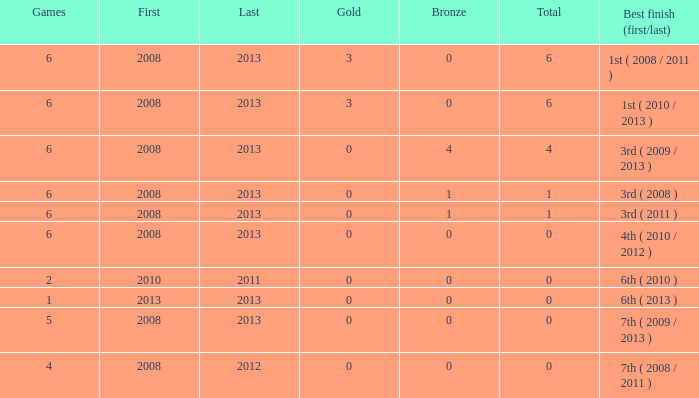How many games have a connection with over 0 golds and a starting year earlier than 2008? None. 